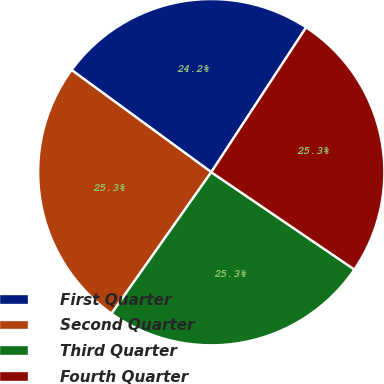Convert chart to OTSL. <chart><loc_0><loc_0><loc_500><loc_500><pie_chart><fcel>First Quarter<fcel>Second Quarter<fcel>Third Quarter<fcel>Fourth Quarter<nl><fcel>24.18%<fcel>25.27%<fcel>25.27%<fcel>25.27%<nl></chart> 